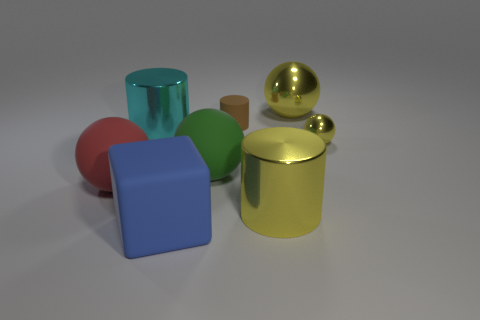Do the big blue object and the tiny object that is to the left of the small yellow thing have the same material?
Provide a succinct answer. Yes. What is the color of the other matte ball that is the same size as the red ball?
Offer a very short reply. Green. There is a metal sphere behind the large metallic cylinder behind the red object; how big is it?
Offer a terse response. Large. Do the small ball and the big thing behind the cyan cylinder have the same color?
Your answer should be very brief. Yes. Is the number of tiny brown rubber cylinders that are on the left side of the rubber block less than the number of tiny yellow metal things?
Provide a short and direct response. Yes. How many other objects are there of the same size as the matte cylinder?
Make the answer very short. 1. There is a large rubber thing to the right of the rubber cube; is it the same shape as the red rubber object?
Offer a very short reply. Yes. Is the number of rubber things that are to the right of the big green matte thing greater than the number of gray cylinders?
Provide a short and direct response. Yes. What is the object that is in front of the large red rubber ball and behind the blue matte thing made of?
Provide a succinct answer. Metal. Is there any other thing that has the same shape as the big blue matte object?
Keep it short and to the point. No. 